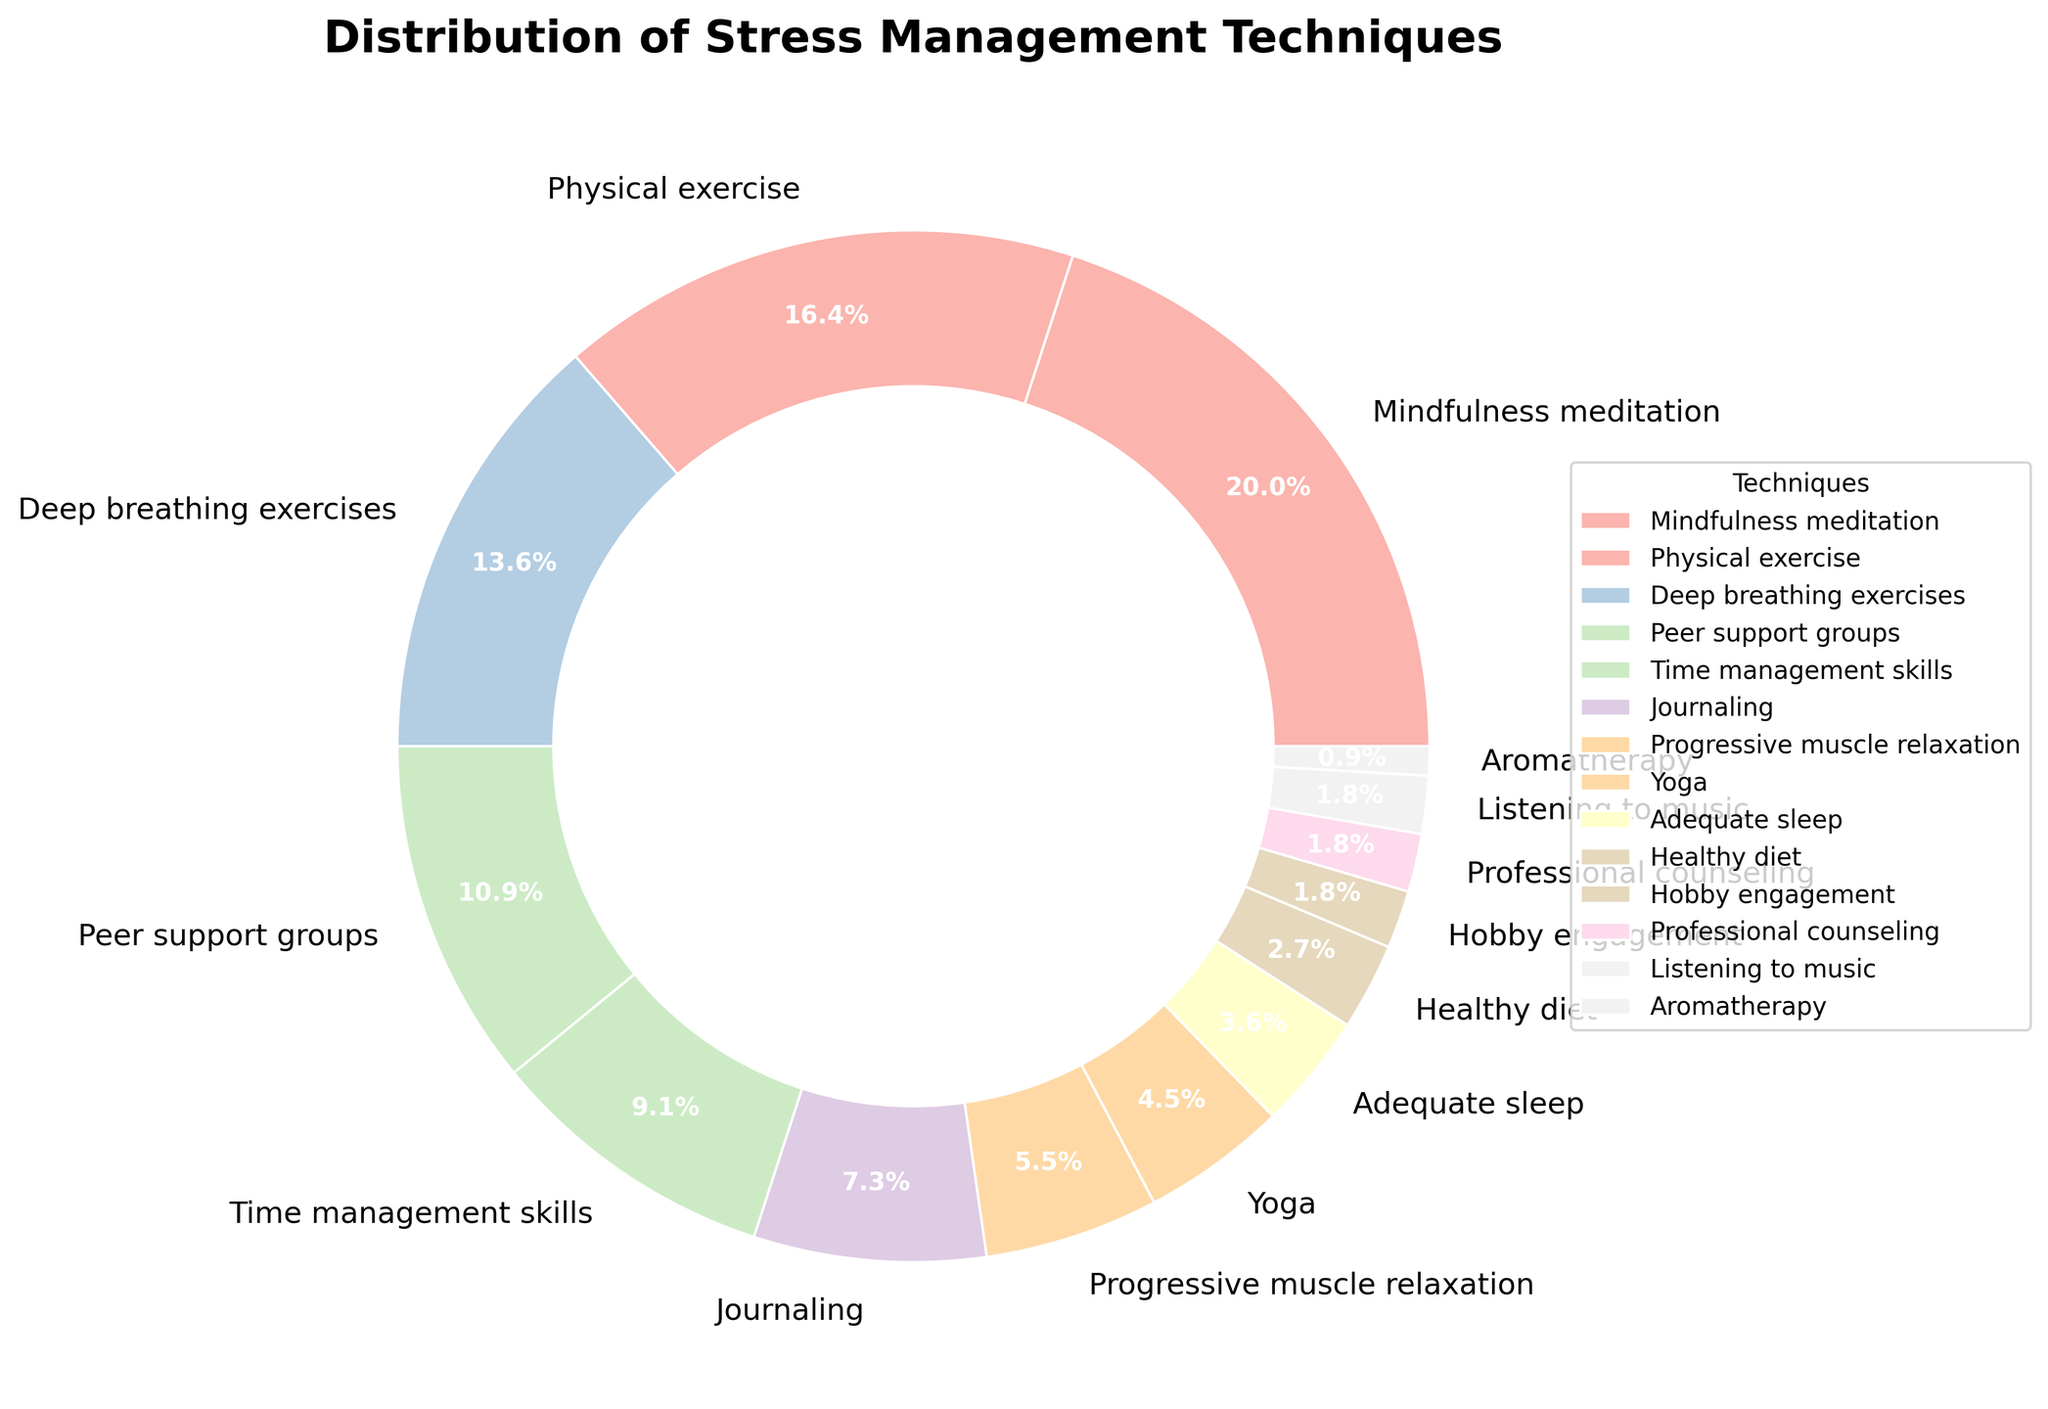Which stress management technique is used the most by trainees? The pie chart's largest segment represents the most used technique. Observing the figure, the largest segment belongs to Mindfulness meditation.
Answer: Mindfulness meditation Which stress management techniques are equally used at the lowest percentage? Locate the smallest segments in the pie chart that have the same percentage value. The chart indicates that Hobby engagement, Professional counseling, and Listening to music each have 2%.
Answer: Hobby engagement, Professional counseling, Listening to music What is the total percentage of trainees using physical exercise and deep breathing exercises? Sum the percentages of Physical exercise (18%) and Deep breathing exercises (15%) to get the total combined percentage. 18 + 15 = 33%
Answer: 33% Compare the usage of Peer support groups to Yoga. Which one is used more? Visual comparison of the segments for Peer support groups and Yoga shows the larger segment. Peer support groups have 12%, while Yoga has 5%, indicating Peer support groups are used more.
Answer: Peer support groups What percentage of trainees use techniques related to relaxation (Deep breathing exercises + Progressive muscle relaxation)? Add the percentages for Deep breathing exercises (15%) and Progressive muscle relaxation (6%). 15 + 6 = 21%
Answer: 21% Which stress management techniques account for less than 5% each? Examine the pie chart segments that represent less than 5%. The techniques are Yoga (5%), Adequate sleep (4%), Healthy diet (3%), Hobby engagement (2%), Professional counseling (2%), Listening to music (2%), and Aromatherapy (1%).
Answer: Yoga, Adequate sleep, Healthy diet, Hobby engagement, Professional counseling, Listening to music, Aromatherapy How does the use of Time management skills compare to Journaling? Compare the sizes of the pie chart segments for Time management skills (10%) and Journaling (8%). Time management skills are used more because 10% is greater than 8%.
Answer: Time management skills What's the combined percentage of techniques used by less than or equal to 6% of trainees? Add the percentages of techniques used by less than or equal to 6%. These techniques are Progressive muscle relaxation (6%), Yoga (5%), Adequate sleep (4%), Healthy diet (3%), Hobby engagement (2%), Professional counseling (2%), Listening to music (2%), and Aromatherapy (1%). 6 + 5 + 4 + 3 + 2 + 2 + 2 + 1 = 25%
Answer: 25% What is the visual representation color scheme used for the pie chart? The pie chart uses pastel colors for visual representation. This is evident from the soft and light color shades seen in each segment of the pie chart, suggesting a pastel color scheme.
Answer: Pastel colors Which technique is used by exactly 12% of trainees? Locate the segment of the pie chart labeled with 12%. This segment represents Peer support groups.
Answer: Peer support groups 